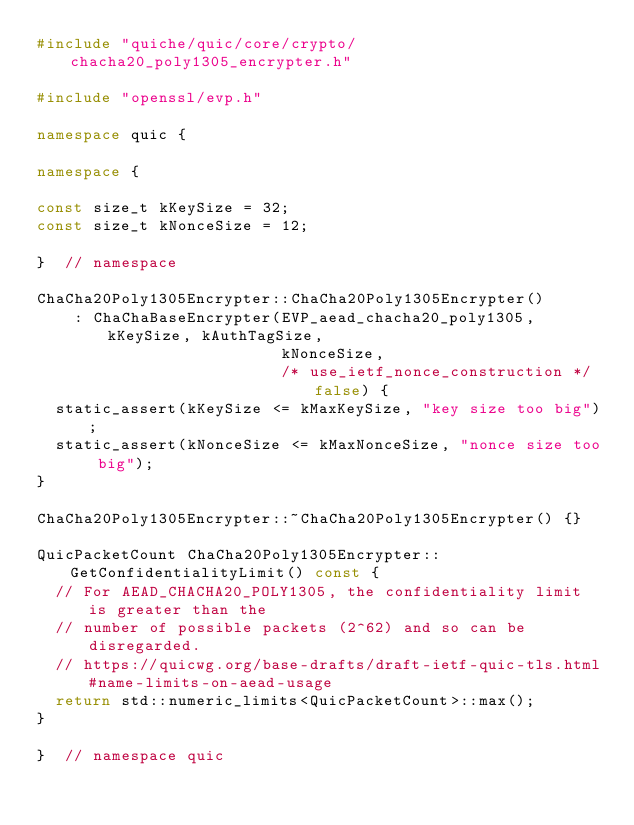Convert code to text. <code><loc_0><loc_0><loc_500><loc_500><_C++_>#include "quiche/quic/core/crypto/chacha20_poly1305_encrypter.h"

#include "openssl/evp.h"

namespace quic {

namespace {

const size_t kKeySize = 32;
const size_t kNonceSize = 12;

}  // namespace

ChaCha20Poly1305Encrypter::ChaCha20Poly1305Encrypter()
    : ChaChaBaseEncrypter(EVP_aead_chacha20_poly1305, kKeySize, kAuthTagSize,
                          kNonceSize,
                          /* use_ietf_nonce_construction */ false) {
  static_assert(kKeySize <= kMaxKeySize, "key size too big");
  static_assert(kNonceSize <= kMaxNonceSize, "nonce size too big");
}

ChaCha20Poly1305Encrypter::~ChaCha20Poly1305Encrypter() {}

QuicPacketCount ChaCha20Poly1305Encrypter::GetConfidentialityLimit() const {
  // For AEAD_CHACHA20_POLY1305, the confidentiality limit is greater than the
  // number of possible packets (2^62) and so can be disregarded.
  // https://quicwg.org/base-drafts/draft-ietf-quic-tls.html#name-limits-on-aead-usage
  return std::numeric_limits<QuicPacketCount>::max();
}

}  // namespace quic
</code> 